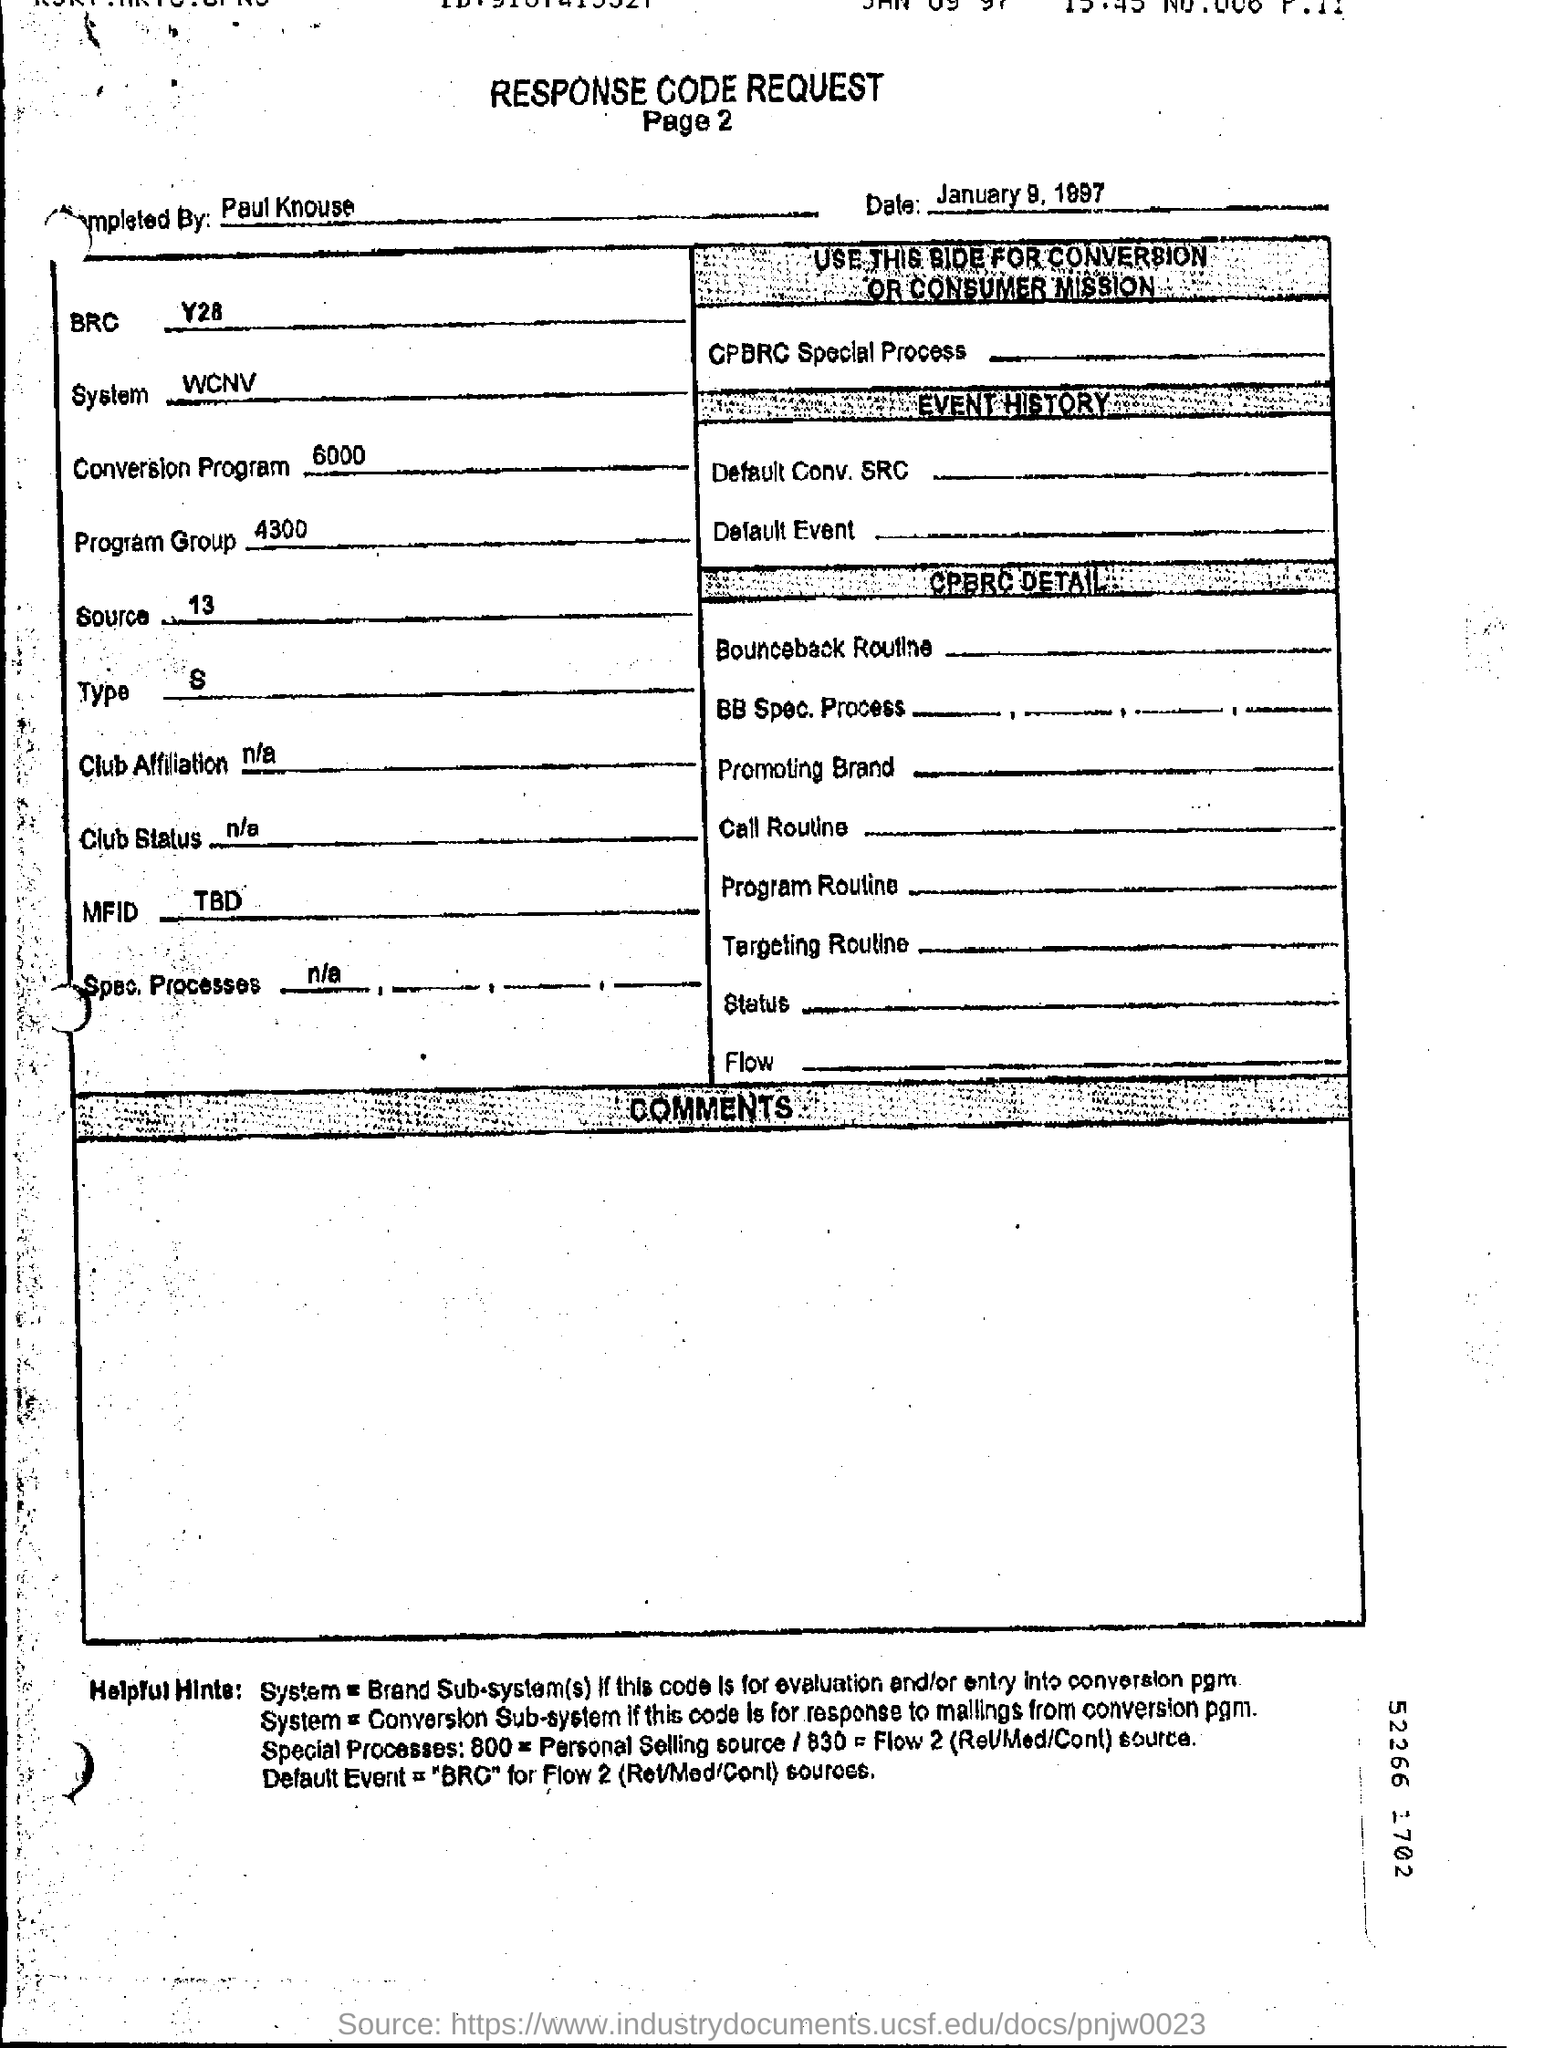Who was it completed by?
Your answer should be compact. Paul Knouse. What is the Date?
Your response must be concise. January 9, 1997. What is the BRC?
Your response must be concise. Y28. What is the system?
Provide a short and direct response. WCNV. What is the conversion program?
Provide a succinct answer. 6000. What is the program group?
Provide a short and direct response. 4300. What is the Source?
Offer a very short reply. 13. What is the type?
Ensure brevity in your answer.  S. What is the Page Number?
Ensure brevity in your answer.  2. What is the Title of the document?
Provide a short and direct response. Response Code Request. 